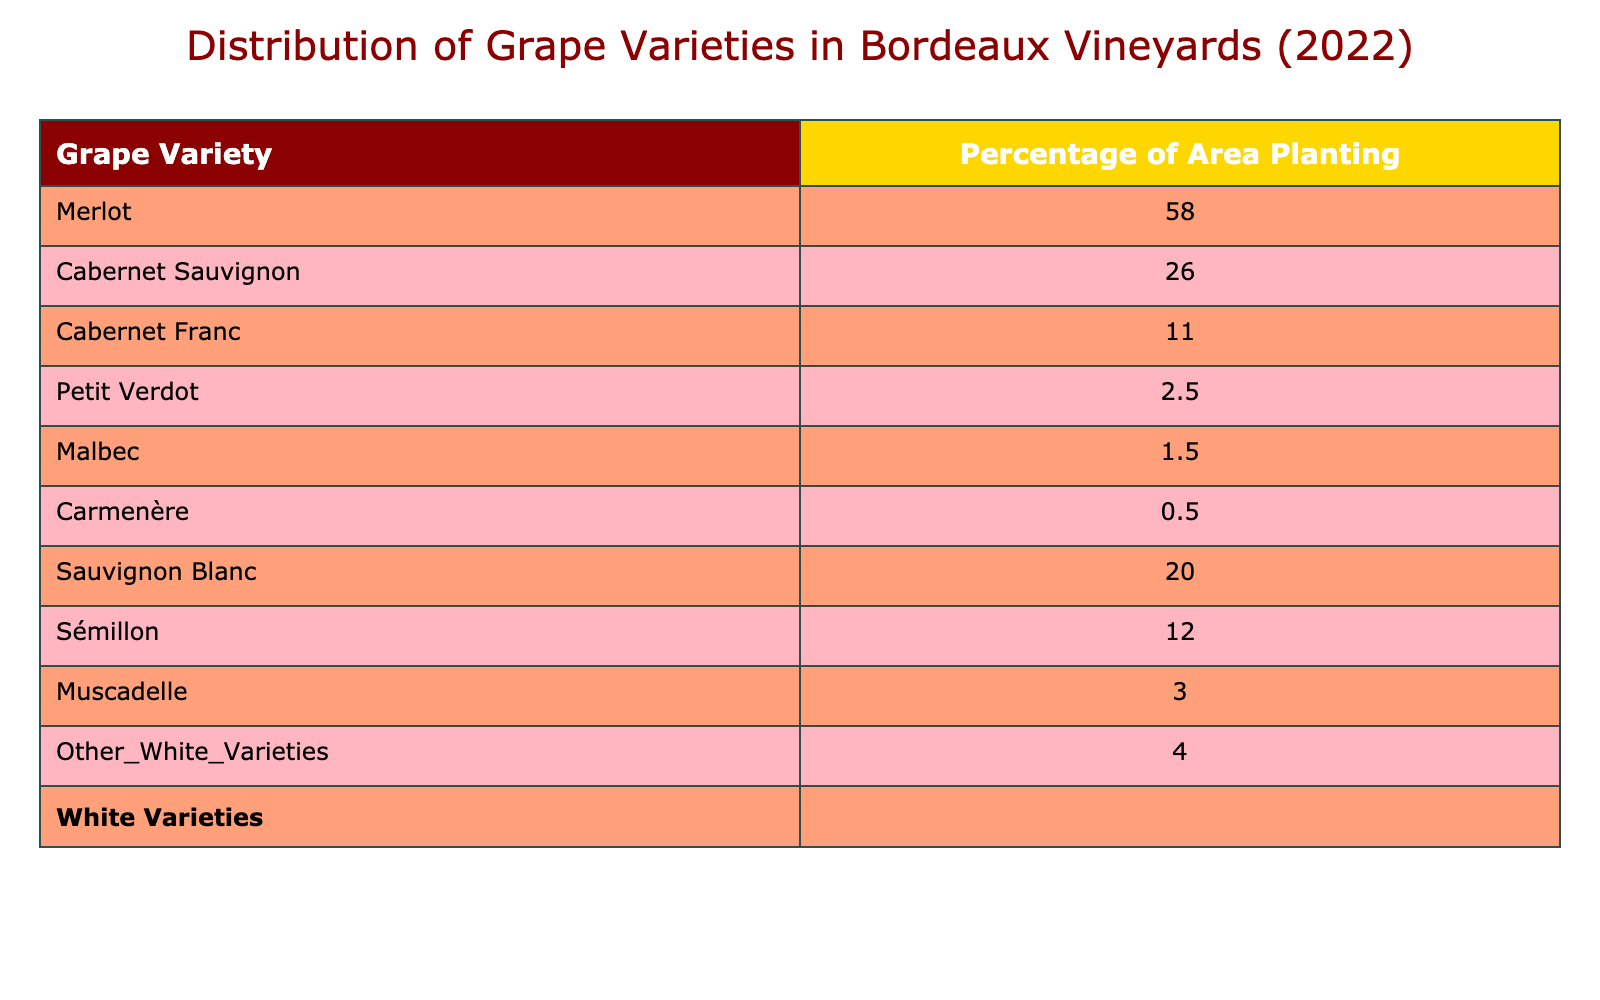What percentage of area planting is represented by Merlot? The table indicates that Merlot accounts for 58.0% of the area planting, as this specific percentage is listed next to the Merlot entry in the table.
Answer: 58.0% Which grape variety has the lowest percentage of area planting? By examining the percentages in the table, Malbec, with 1.5%, is the variety with the lowest percentage, as no other variety has a smaller value listed.
Answer: Malbec What is the total percentage of area planting for white grape varieties? Summing the percentages for white grape varieties, we find 20.0% (Sauvignon Blanc) + 12.0% (Sémillon) + 3.0% (Muscadelle) + 4.0% (Other White Varieties) gives us a total of 39.0%.
Answer: 39.0% Are there more red grape varieties than white grape varieties planted in Bordeaux vineyards? The table lists 6 red grape varieties (Merlot, Cabernet Sauvignon, Cabernet Franc, Petit Verdot, Malbec, Carmenère) and 4 white grape varieties (Sauvignon Blanc, Sémillon, Muscadelle, Other White Varieties). Thus, there are more red varieties than white.
Answer: Yes What percentage of area planting do Cabernet Sauvignon and Cabernet Franc combined represent? Adding the area plantings for Cabernet Sauvignon (26.0%) and Cabernet Franc (11.0%), the total is 37.0%. This reflects the combined area for these two grape varieties.
Answer: 37.0% What is the percentage of area planting for Petit Verdot? Referring to the table, it is noted that Petit Verdot represents 2.5% of the area planting, as listed next to its entry.
Answer: 2.5% Do white grape varieties account for more than 30% of the total area planting? The previous calculations showed that the total for white grape varieties is 39.0%, which indeed exceeds 30%. Therefore, it is true that they account for more than that percentage.
Answer: Yes What percentage of the vineyard is occupied by the top three grape varieties combined? We calculate this by adding the top three varieties: Merlot (58.0%), Cabernet Sauvignon (26.0%), and Cabernet Franc (11.0%). Their sum is 95.0%.
Answer: 95.0% Is the proportion of Carmenère higher than that of Malbec in the vineyard area? Comparing the two percentages, Carmenère accounts for 0.5% while Malbec accounts for 1.5%. Since 0.5% is less than 1.5%, the statement is false.
Answer: No 